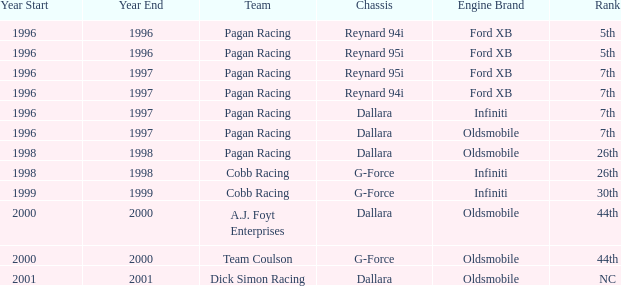What rank did the chassis reynard 94i have in 1996? 5th. 